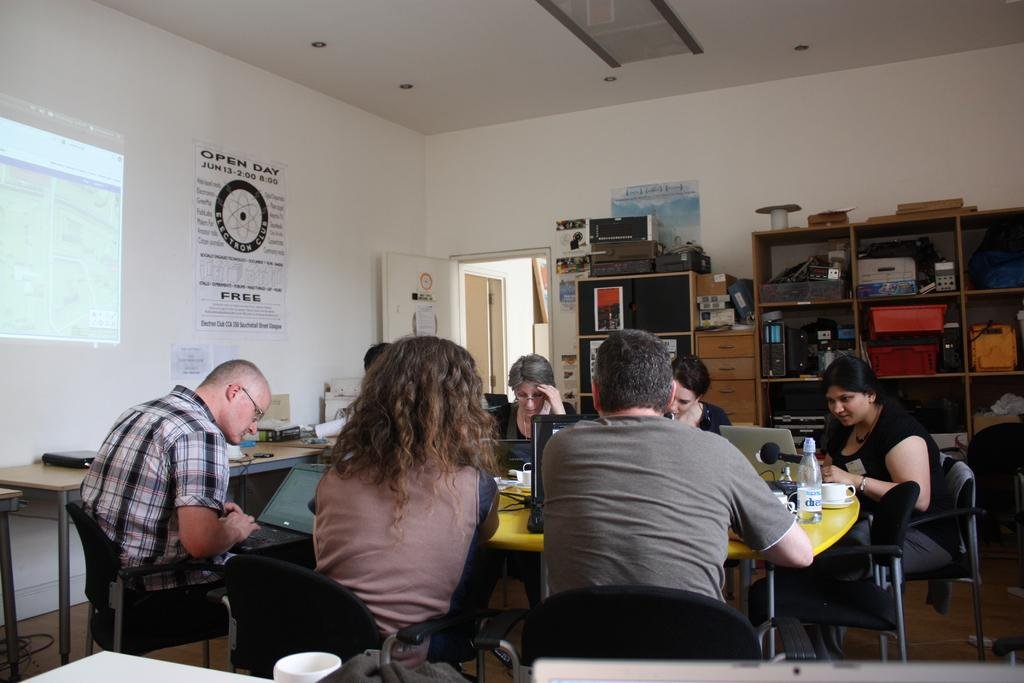How many people are in the image? There is a group of people in the image, but the exact number cannot be determined from the provided facts. What are the people sitting in front of? The people are sitting in front of a yellow table. What can be seen on the yellow table? There are laptops on the yellow table. What is visible in the left corner of the image? There is a projected image in the left corner of the image. What color is the wall in the image? The wall is white in color. What type of flame can be seen coming from the oven in the image? There is no oven present in the image, so it is not possible to determine if there is a flame or not. 